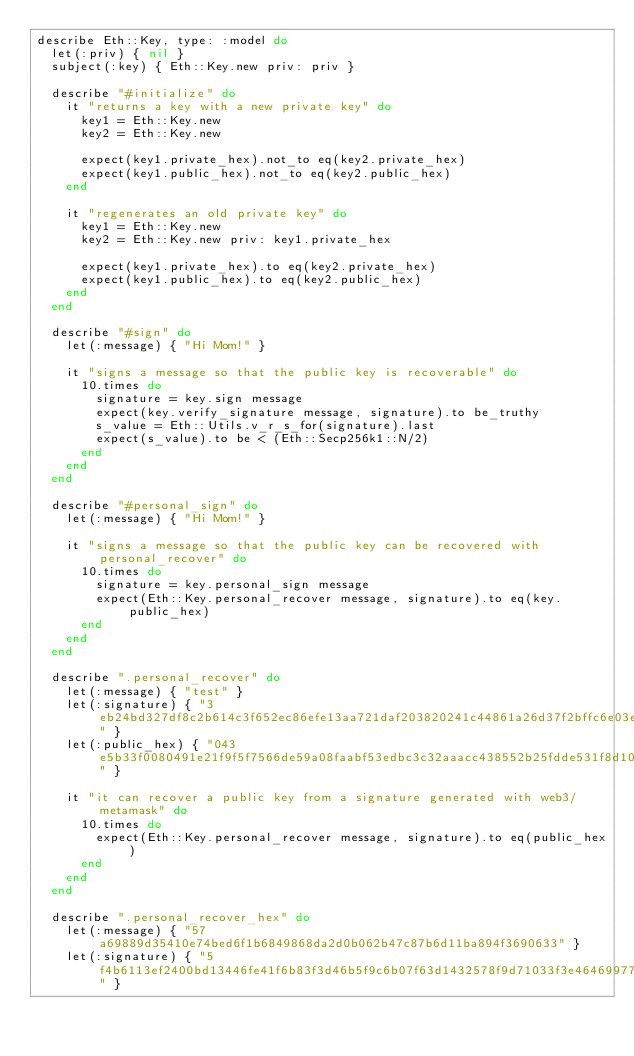Convert code to text. <code><loc_0><loc_0><loc_500><loc_500><_Ruby_>describe Eth::Key, type: :model do
  let(:priv) { nil }
  subject(:key) { Eth::Key.new priv: priv }

  describe "#initialize" do
    it "returns a key with a new private key" do
      key1 = Eth::Key.new
      key2 = Eth::Key.new

      expect(key1.private_hex).not_to eq(key2.private_hex)
      expect(key1.public_hex).not_to eq(key2.public_hex)
    end

    it "regenerates an old private key" do
      key1 = Eth::Key.new
      key2 = Eth::Key.new priv: key1.private_hex

      expect(key1.private_hex).to eq(key2.private_hex)
      expect(key1.public_hex).to eq(key2.public_hex)
    end
  end

  describe "#sign" do
    let(:message) { "Hi Mom!" }

    it "signs a message so that the public key is recoverable" do
      10.times do
        signature = key.sign message
        expect(key.verify_signature message, signature).to be_truthy
        s_value = Eth::Utils.v_r_s_for(signature).last
        expect(s_value).to be < (Eth::Secp256k1::N/2)
      end
    end
  end

  describe "#personal_sign" do
    let(:message) { "Hi Mom!" }

    it "signs a message so that the public key can be recovered with personal_recover" do
      10.times do
        signature = key.personal_sign message
        expect(Eth::Key.personal_recover message, signature).to eq(key.public_hex)
      end
    end
  end

  describe ".personal_recover" do
    let(:message) { "test" }
    let(:signature) { "3eb24bd327df8c2b614c3f652ec86efe13aa721daf203820241c44861a26d37f2bffc6e03e68fc4c3d8d967054c9cb230ed34339b12ef89d512b42ae5bf8c2ae1c" }
    let(:public_hex) { "043e5b33f0080491e21f9f5f7566de59a08faabf53edbc3c32aaacc438552b25fdde531f8d1053ced090e9879cbf2b0d1c054e4b25941dab9254d2070f39418afc" }

    it "it can recover a public key from a signature generated with web3/metamask" do
      10.times do
        expect(Eth::Key.personal_recover message, signature).to eq(public_hex)
      end
    end
  end

  describe ".personal_recover_hex" do
    let(:message) { "57a69889d35410e74bed6f1b6849868da2d0b062b47c87b6d11ba894f3690633" }
    let(:signature) { "5f4b6113ef2400bd13446fe41f6b83f3d46b5f9c6b07f63d1432578f9d71033f3e464699775521aa5ea55b4eb44b7c6ae5482c95c328d064ba60e6ffe25c4b6d1b" }</code> 